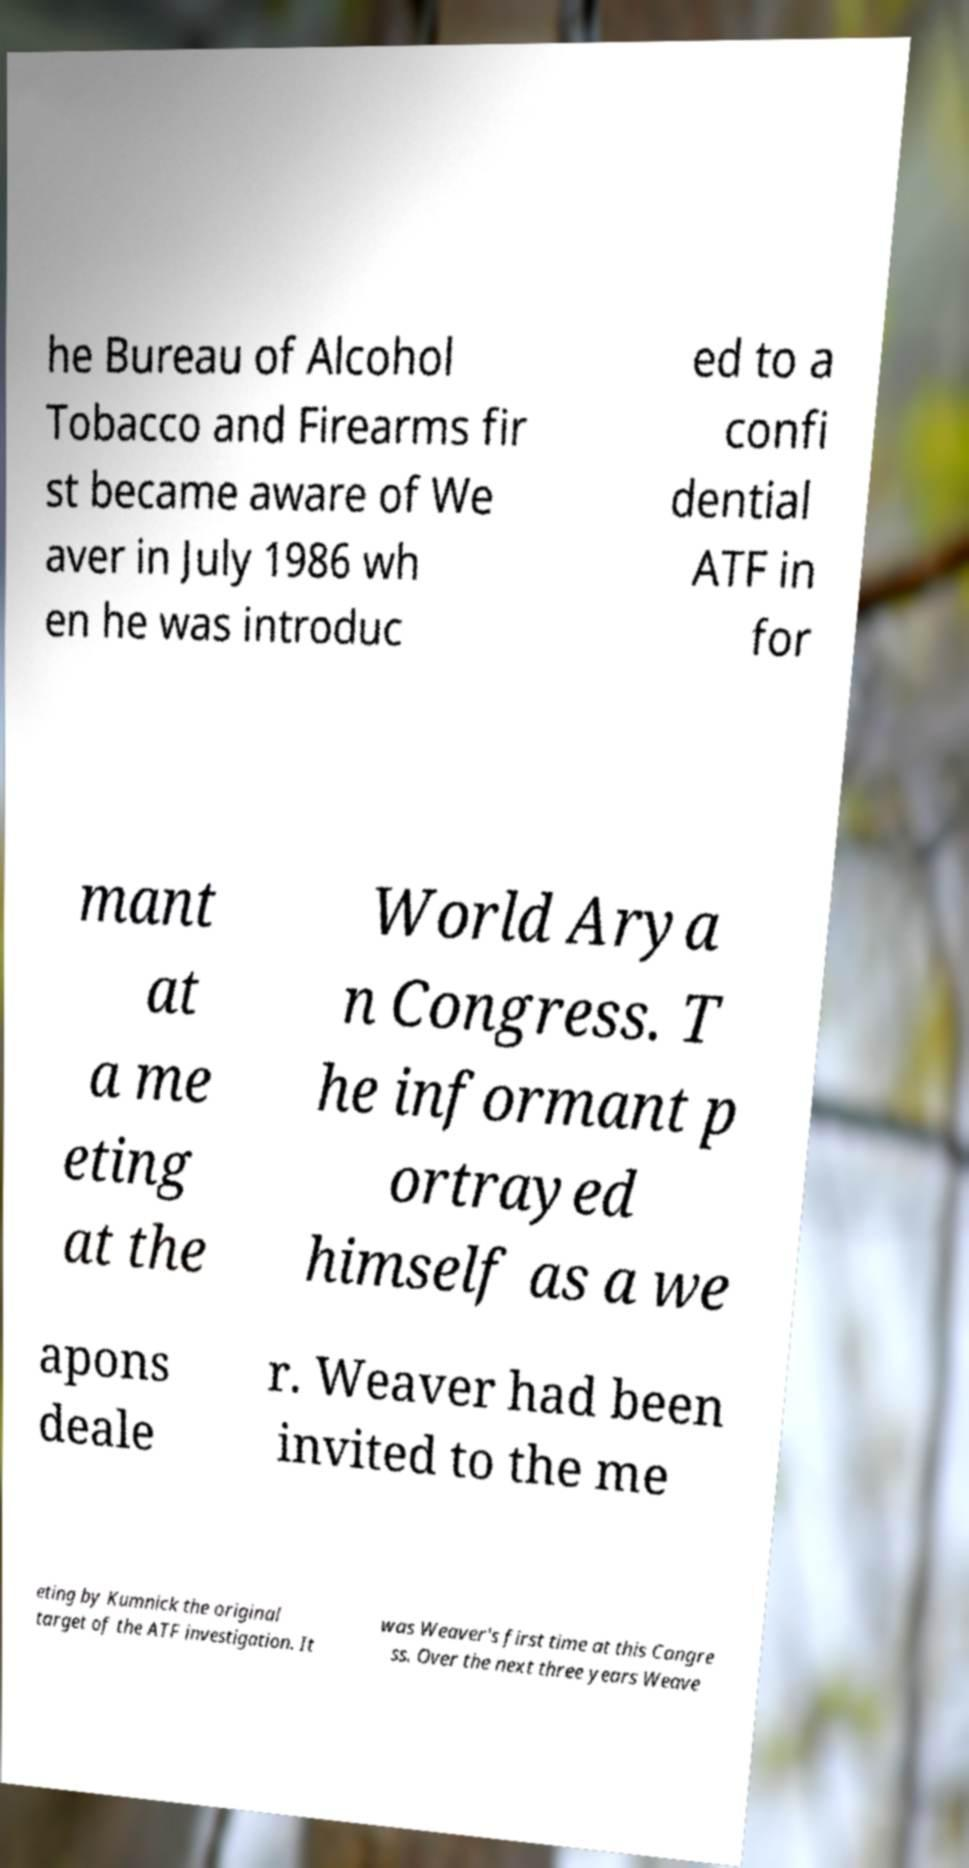I need the written content from this picture converted into text. Can you do that? he Bureau of Alcohol Tobacco and Firearms fir st became aware of We aver in July 1986 wh en he was introduc ed to a confi dential ATF in for mant at a me eting at the World Arya n Congress. T he informant p ortrayed himself as a we apons deale r. Weaver had been invited to the me eting by Kumnick the original target of the ATF investigation. It was Weaver's first time at this Congre ss. Over the next three years Weave 